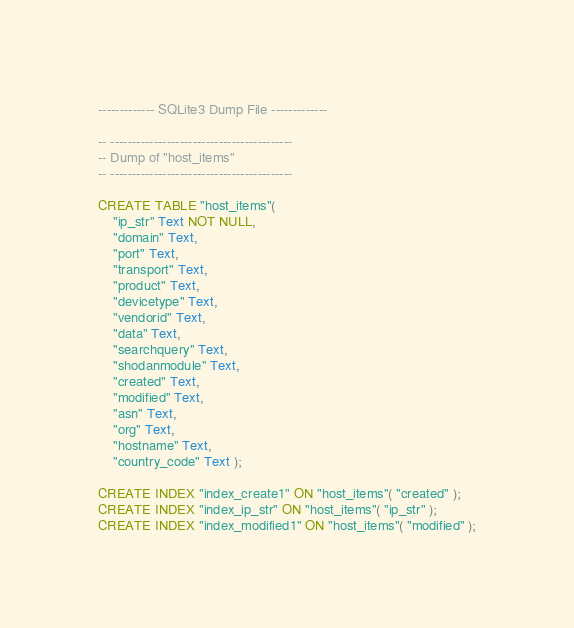Convert code to text. <code><loc_0><loc_0><loc_500><loc_500><_SQL_>------------- SQLite3 Dump File -------------

-- ------------------------------------------
-- Dump of "host_items"
-- ------------------------------------------

CREATE TABLE "host_items"(
	"ip_str" Text NOT NULL,
	"domain" Text,
	"port" Text,
	"transport" Text,
	"product" Text,
	"devicetype" Text,
	"vendorid" Text,
	"data" Text,
	"searchquery" Text,
	"shodanmodule" Text,
	"created" Text,
	"modified" Text,
	"asn" Text,
	"org" Text,
	"hostname" Text,
	"country_code" Text );

CREATE INDEX "index_create1" ON "host_items"( "created" );
CREATE INDEX "index_ip_str" ON "host_items"( "ip_str" );
CREATE INDEX "index_modified1" ON "host_items"( "modified" );

</code> 